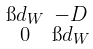Convert formula to latex. <formula><loc_0><loc_0><loc_500><loc_500>\begin{smallmatrix} \i d _ { W } & - D \\ 0 & \i d _ { W } \end{smallmatrix}</formula> 